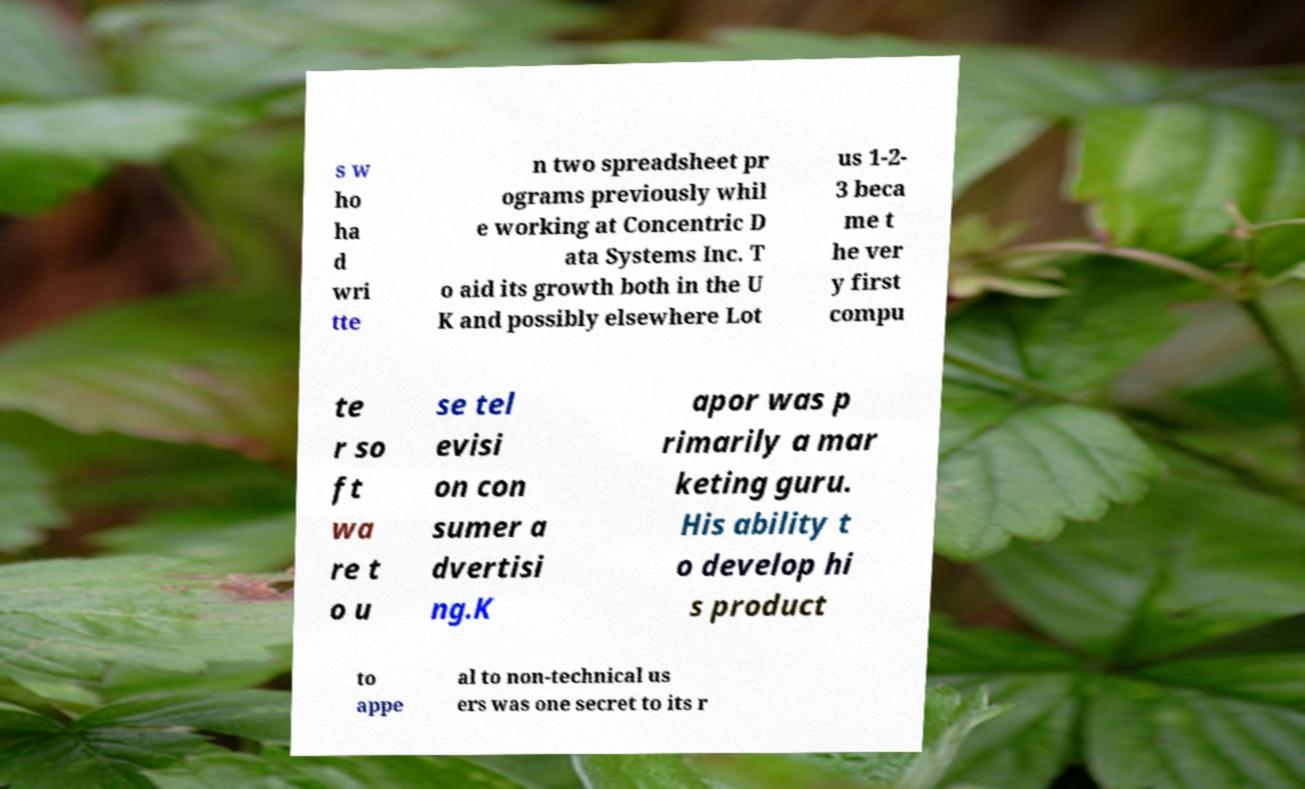Please identify and transcribe the text found in this image. s w ho ha d wri tte n two spreadsheet pr ograms previously whil e working at Concentric D ata Systems Inc. T o aid its growth both in the U K and possibly elsewhere Lot us 1-2- 3 beca me t he ver y first compu te r so ft wa re t o u se tel evisi on con sumer a dvertisi ng.K apor was p rimarily a mar keting guru. His ability t o develop hi s product to appe al to non-technical us ers was one secret to its r 